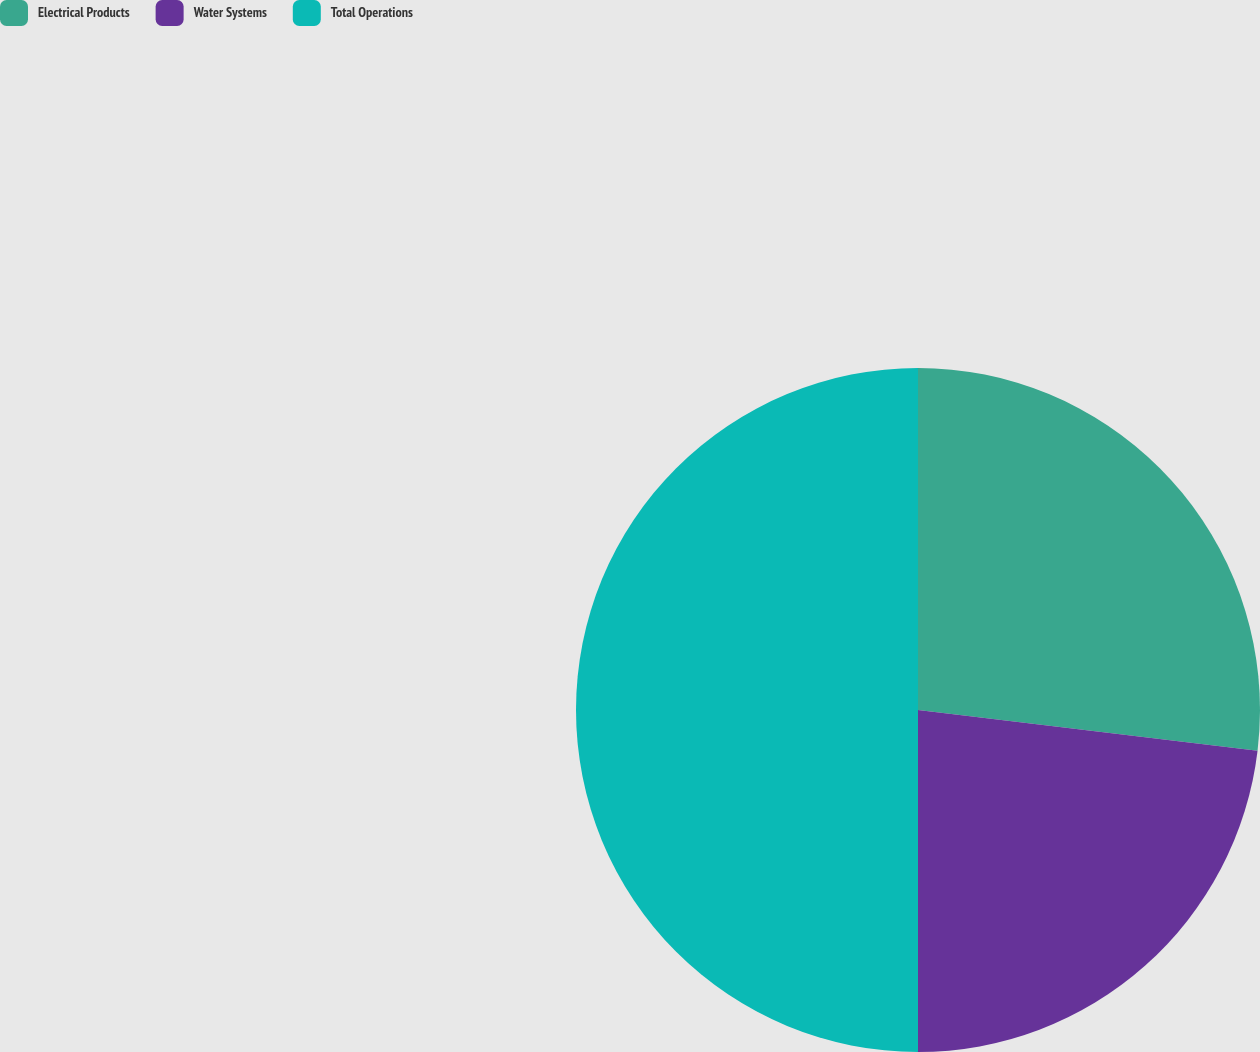<chart> <loc_0><loc_0><loc_500><loc_500><pie_chart><fcel>Electrical Products<fcel>Water Systems<fcel>Total Operations<nl><fcel>26.9%<fcel>23.1%<fcel>50.0%<nl></chart> 